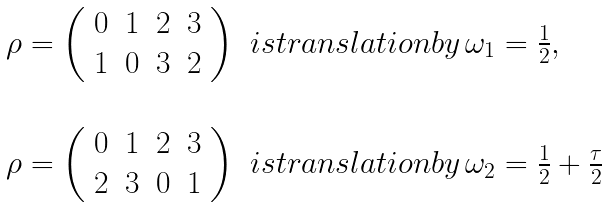<formula> <loc_0><loc_0><loc_500><loc_500>\begin{array} { l l } \rho = \left ( \begin{array} { c c c c } 0 & 1 & 2 & 3 \\ 1 & 0 & 3 & 2 \end{array} \right ) & i s t r a n s l a t i o n b y \, \omega _ { 1 } = \frac { 1 } { 2 } , \\ \\ \rho = \left ( \begin{array} { c c c c } 0 & 1 & 2 & 3 \\ 2 & 3 & 0 & 1 \end{array} \right ) & i s t r a n s l a t i o n b y \, \omega _ { 2 } = \frac { 1 } { 2 } + \frac { \tau } { 2 } \end{array}</formula> 